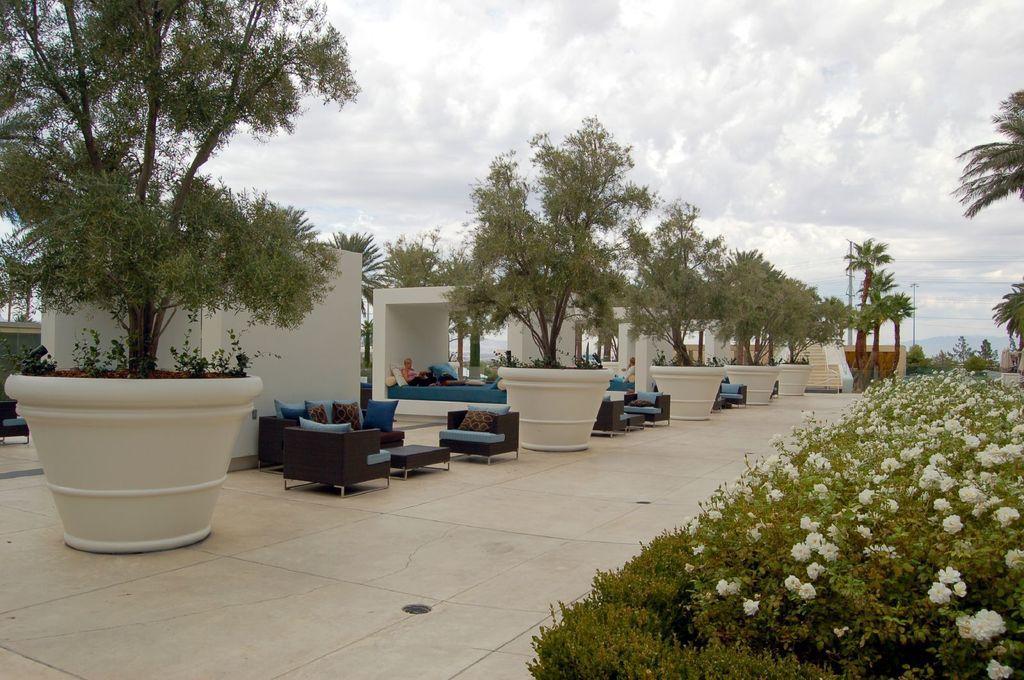Describe this image in one or two sentences. This is open space area,there are sofas,pillows and table to sit and talk. And there is a big flower pot in it there is a tree. The sky is cloudy. On the right there are plants with flowers. There is a bed hare and a person is sitting on it. 